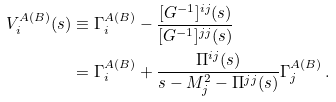<formula> <loc_0><loc_0><loc_500><loc_500>V _ { i } ^ { A ( B ) } ( s ) & \equiv \Gamma _ { i } ^ { A ( B ) } - \frac { [ G ^ { - 1 } ] ^ { i j } ( s ) } { [ G ^ { - 1 } ] ^ { j j } ( s ) } \\ & = \Gamma _ { i } ^ { A ( B ) } + \frac { \Pi ^ { i j } ( s ) } { s - M _ { j } ^ { 2 } - \Pi ^ { j j } ( s ) } \Gamma _ { j } ^ { A ( B ) } \, .</formula> 